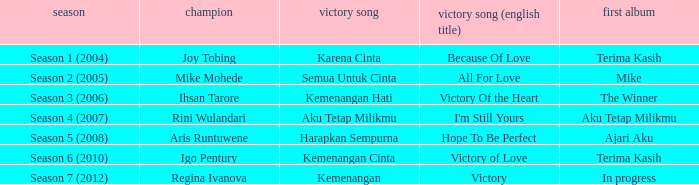Which winning song was sung by aku tetap milikmu? I'm Still Yours. 